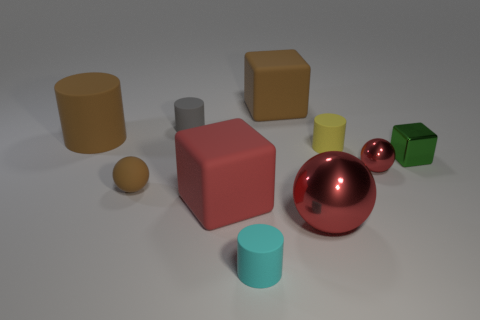How many blocks are cyan objects or small yellow rubber things?
Give a very brief answer. 0. What is the color of the metallic object that is the same size as the green block?
Make the answer very short. Red. The thing in front of the red shiny sphere that is to the left of the tiny yellow matte cylinder is what shape?
Your answer should be compact. Cylinder. There is a brown matte object on the right side of the cyan object; does it have the same size as the red matte object?
Your response must be concise. Yes. How many other things are made of the same material as the small yellow cylinder?
Give a very brief answer. 6. What number of cyan things are either tiny shiny spheres or tiny things?
Provide a short and direct response. 1. There is a rubber thing that is the same color as the tiny metal sphere; what is its size?
Ensure brevity in your answer.  Large. There is a small cyan matte thing; what number of tiny red shiny balls are on the left side of it?
Offer a very short reply. 0. How big is the red metallic ball on the left side of the small ball that is to the right of the large cube behind the red cube?
Provide a succinct answer. Large. There is a cylinder that is on the right side of the matte block that is behind the tiny yellow matte thing; is there a green thing on the right side of it?
Your response must be concise. Yes. 